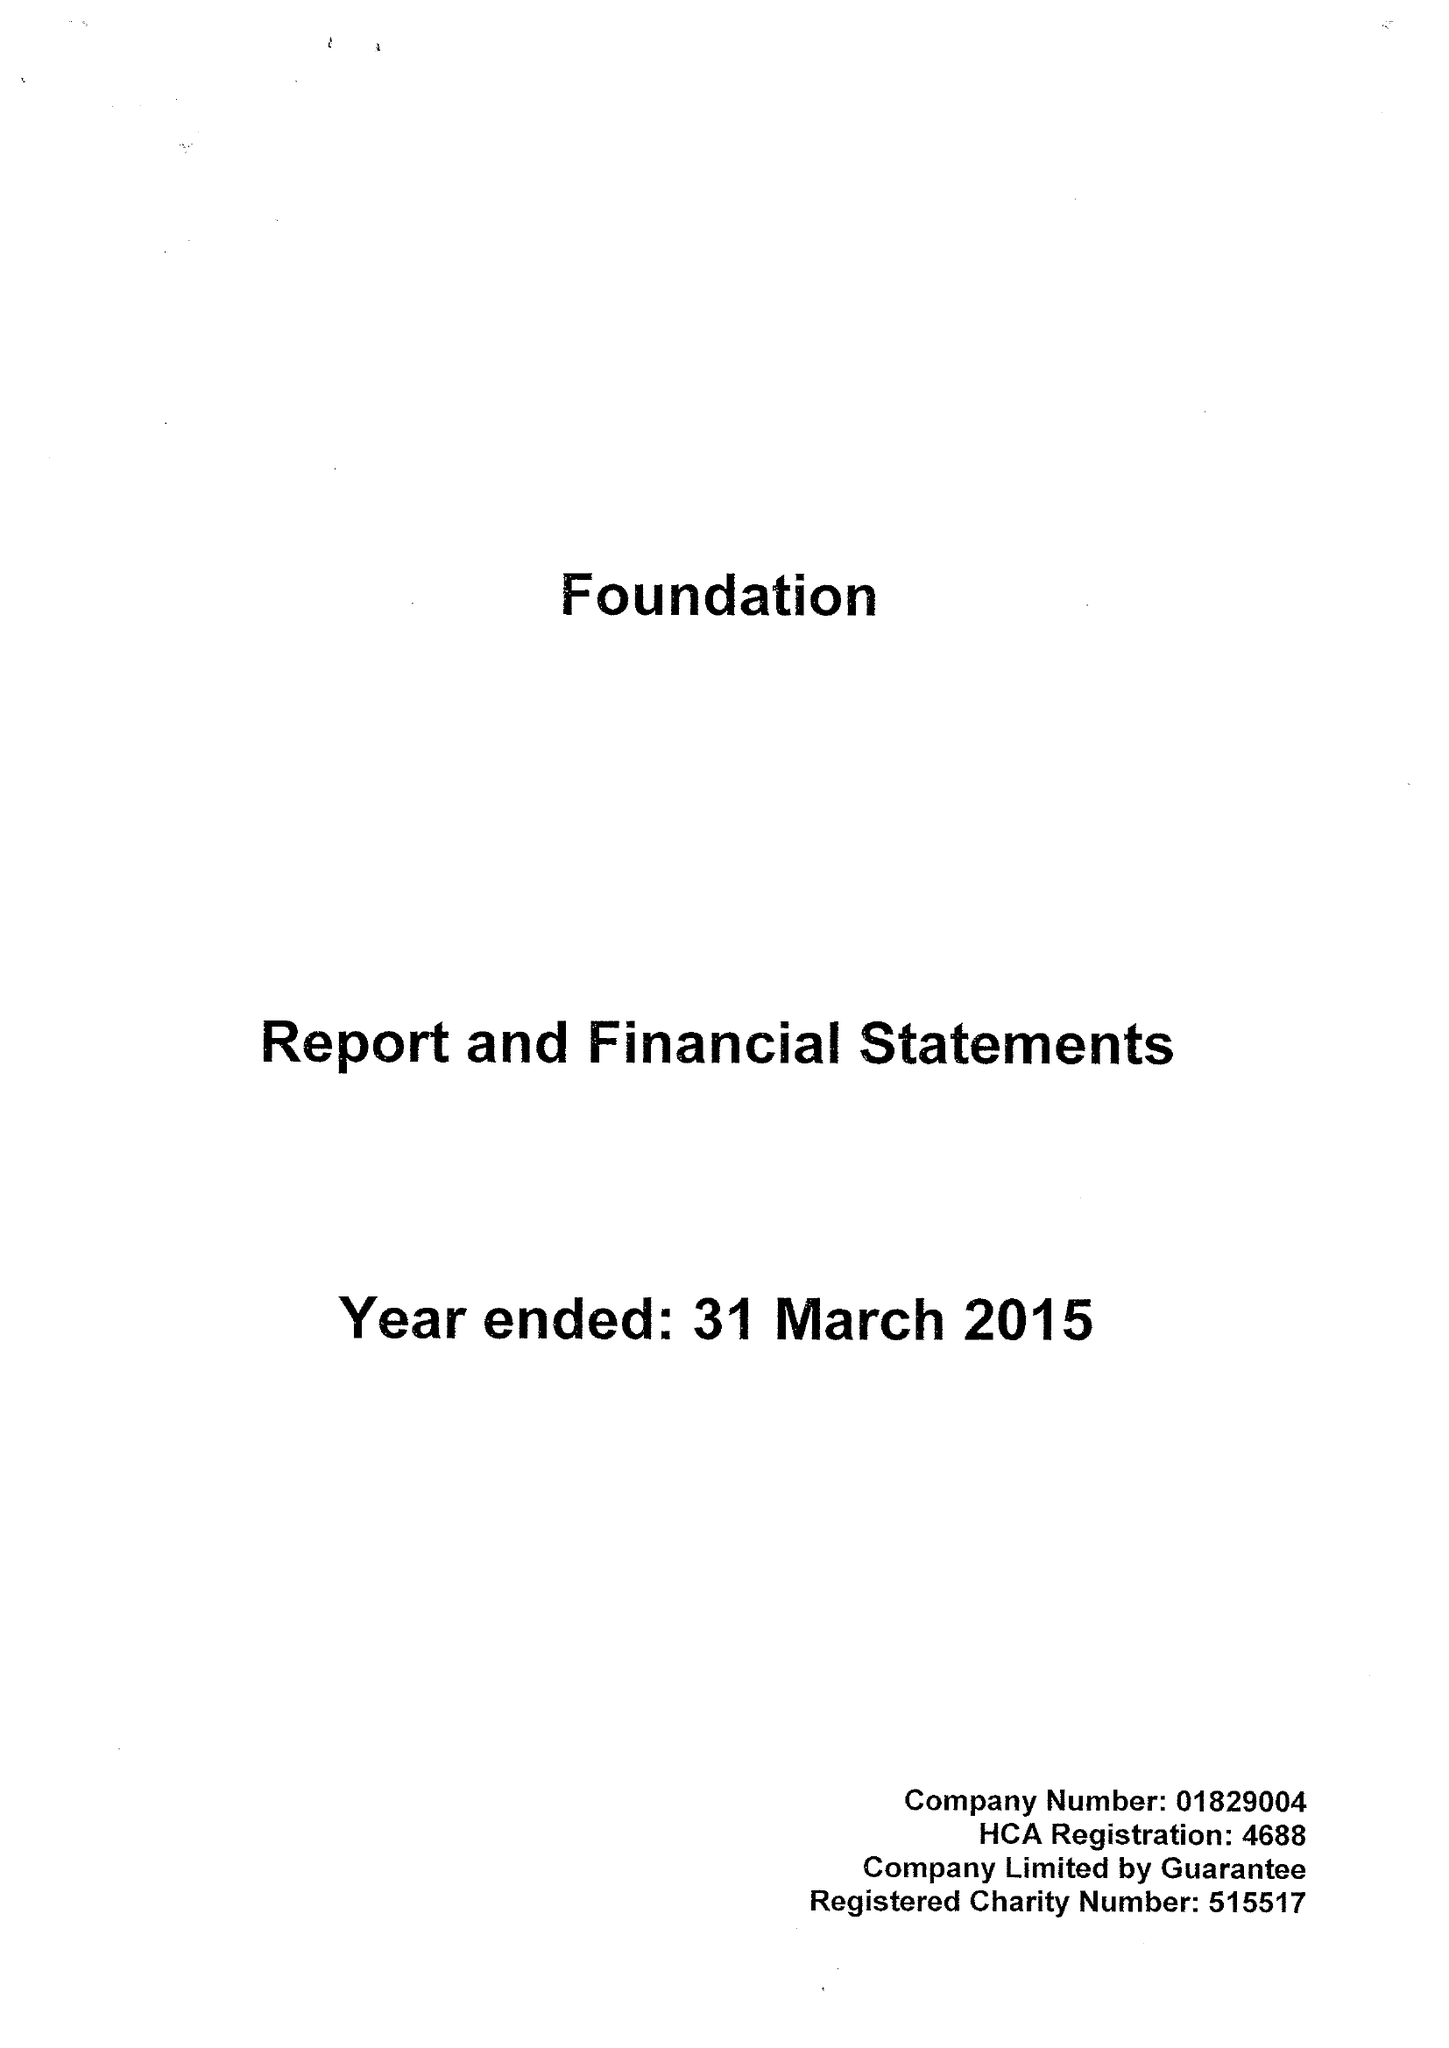What is the value for the report_date?
Answer the question using a single word or phrase. 2015-03-31 